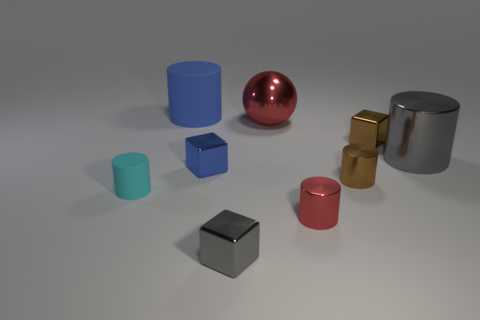Are there any other things that have the same shape as the big red object?
Offer a very short reply. No. There is a gray block that is made of the same material as the small blue block; what is its size?
Your response must be concise. Small. Is there a large red sphere that is left of the small thing that is on the left side of the rubber thing behind the brown cylinder?
Give a very brief answer. No. Does the gray metal thing left of the gray cylinder have the same size as the blue rubber thing?
Provide a short and direct response. No. What number of other cylinders have the same size as the blue matte cylinder?
Offer a terse response. 1. What size is the cylinder that is the same color as the ball?
Your answer should be compact. Small. Is the big rubber thing the same color as the big shiny cylinder?
Offer a very short reply. No. What is the shape of the tiny blue thing?
Provide a short and direct response. Cube. Is there a big thing of the same color as the large metallic sphere?
Offer a terse response. No. Are there more small brown metal cylinders that are left of the big matte thing than big gray metallic cylinders?
Offer a very short reply. No. 